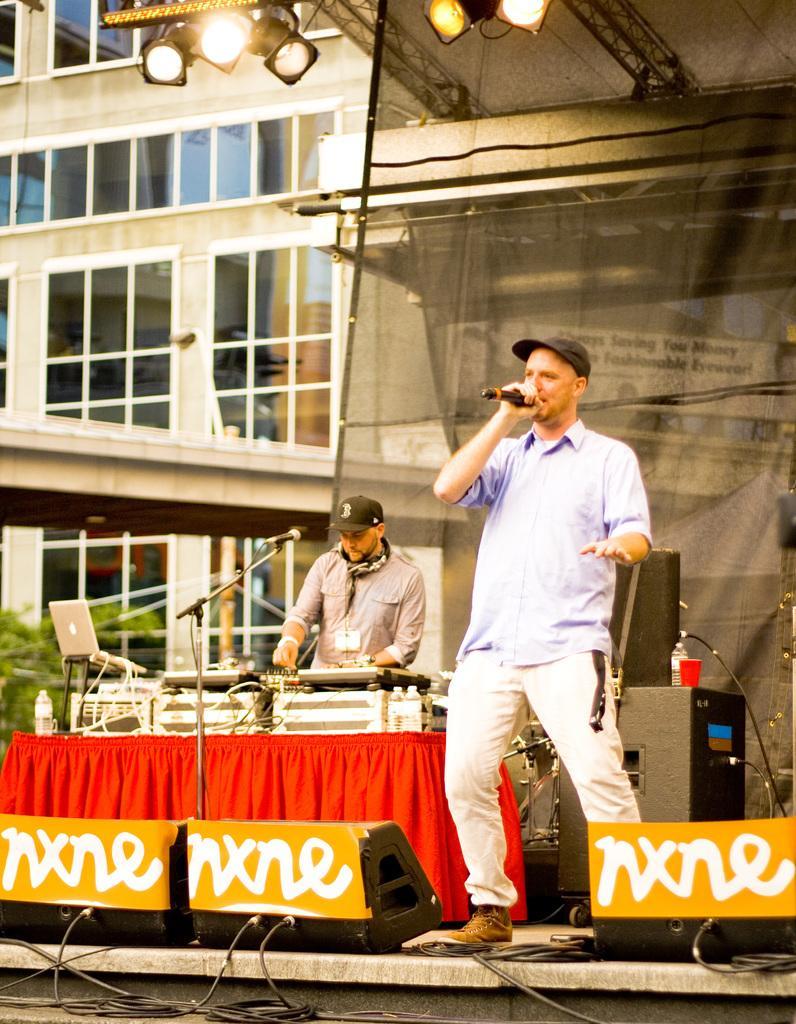How would you summarize this image in a sentence or two? In this image I can see two persons. In front the person is standing and holding a microphone, background I can see the microphone and I can see few musical instruments and a laptop. I can also see few lights and the building is in cream color and I can see few glass windows. 